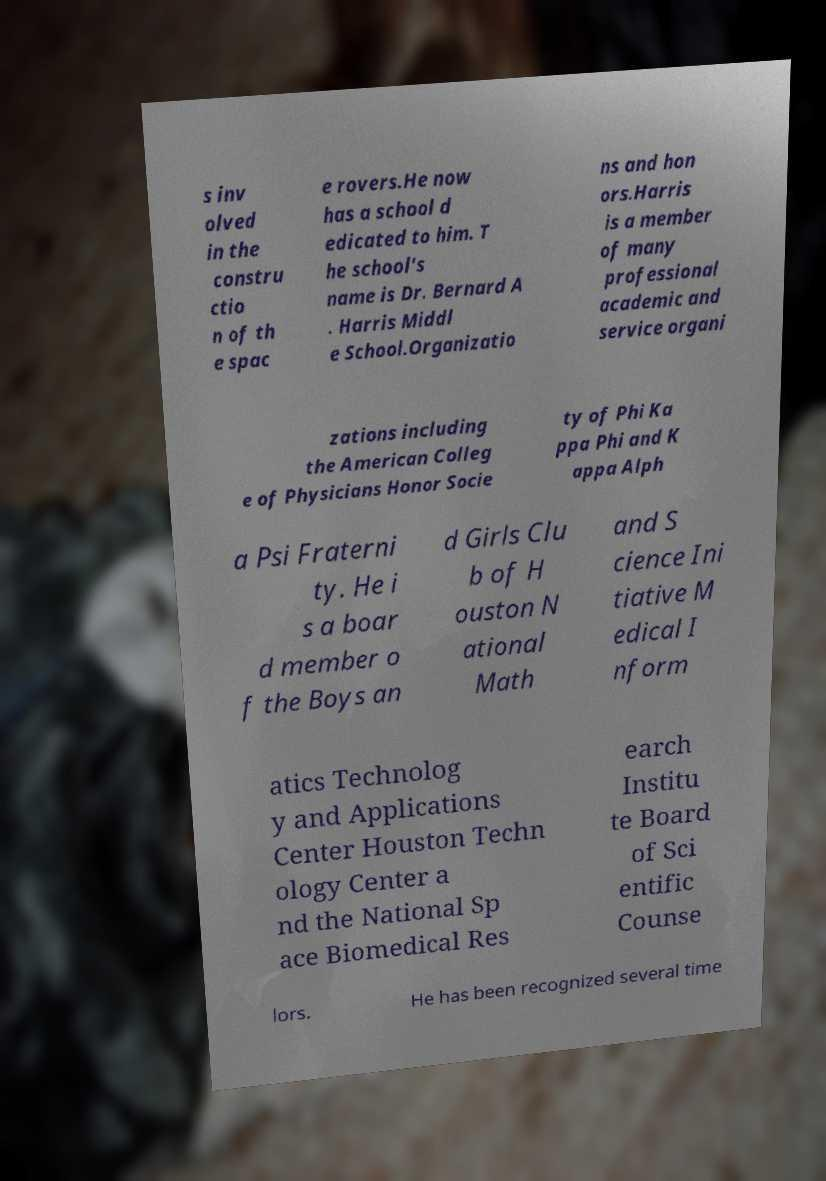Could you assist in decoding the text presented in this image and type it out clearly? s inv olved in the constru ctio n of th e spac e rovers.He now has a school d edicated to him. T he school's name is Dr. Bernard A . Harris Middl e School.Organizatio ns and hon ors.Harris is a member of many professional academic and service organi zations including the American Colleg e of Physicians Honor Socie ty of Phi Ka ppa Phi and K appa Alph a Psi Fraterni ty. He i s a boar d member o f the Boys an d Girls Clu b of H ouston N ational Math and S cience Ini tiative M edical I nform atics Technolog y and Applications Center Houston Techn ology Center a nd the National Sp ace Biomedical Res earch Institu te Board of Sci entific Counse lors. He has been recognized several time 